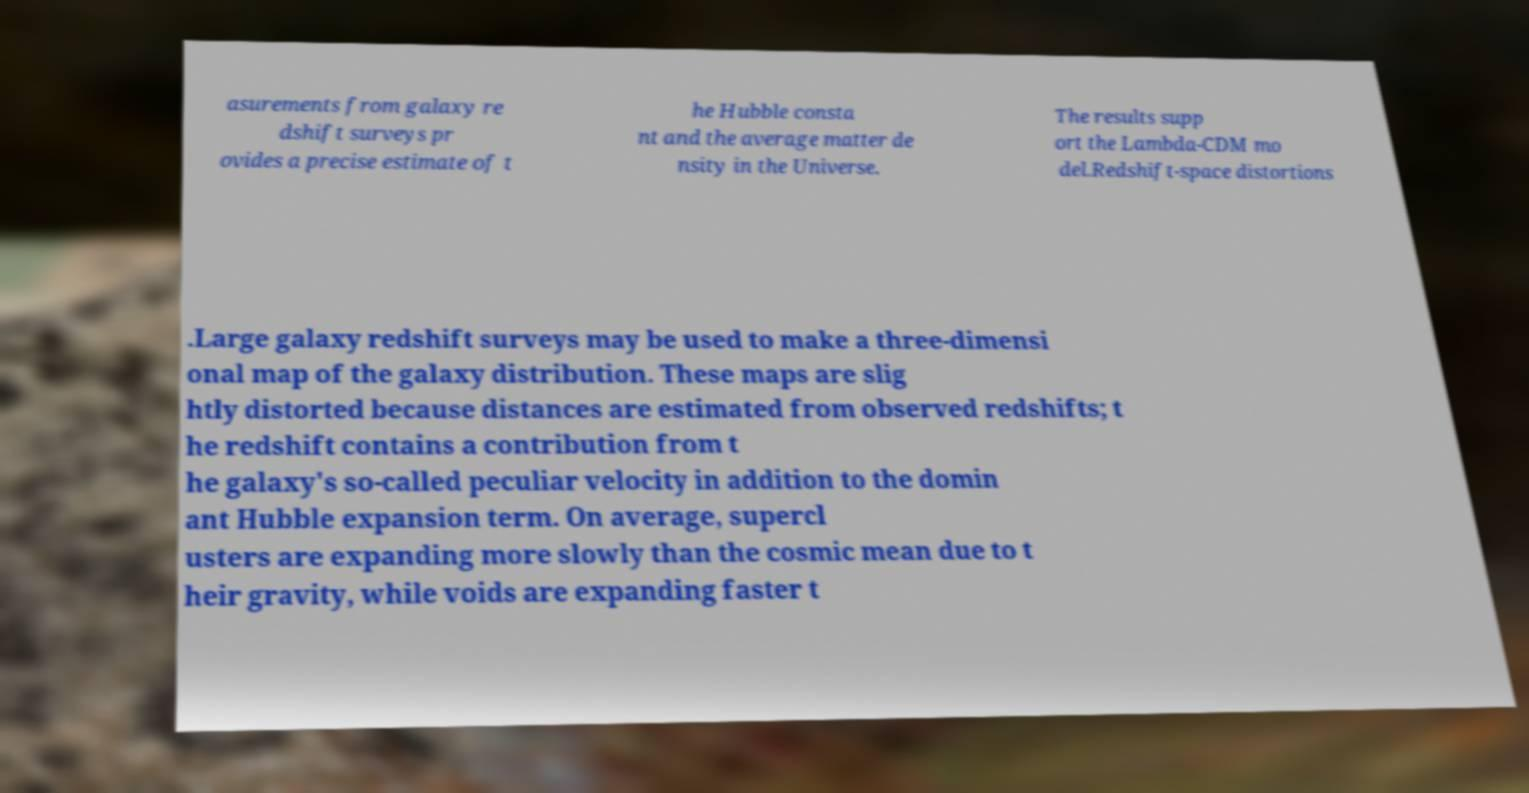There's text embedded in this image that I need extracted. Can you transcribe it verbatim? asurements from galaxy re dshift surveys pr ovides a precise estimate of t he Hubble consta nt and the average matter de nsity in the Universe. The results supp ort the Lambda-CDM mo del.Redshift-space distortions .Large galaxy redshift surveys may be used to make a three-dimensi onal map of the galaxy distribution. These maps are slig htly distorted because distances are estimated from observed redshifts; t he redshift contains a contribution from t he galaxy's so-called peculiar velocity in addition to the domin ant Hubble expansion term. On average, supercl usters are expanding more slowly than the cosmic mean due to t heir gravity, while voids are expanding faster t 